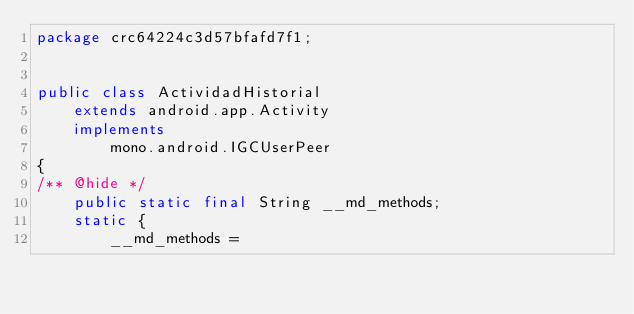Convert code to text. <code><loc_0><loc_0><loc_500><loc_500><_Java_>package crc64224c3d57bfafd7f1;


public class ActividadHistorial
	extends android.app.Activity
	implements
		mono.android.IGCUserPeer
{
/** @hide */
	public static final String __md_methods;
	static {
		__md_methods = </code> 